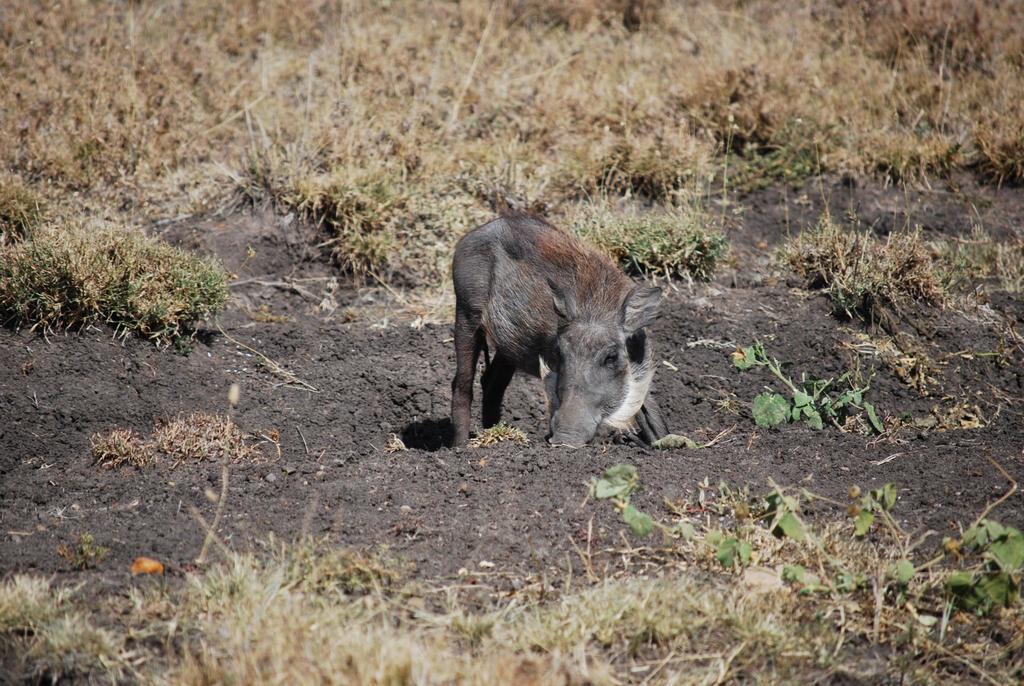Can you describe this image briefly? In this image I can see the ground which is black in color and an animal which is black and white in color on the ground. I can see some grass which is brown and cream in color on the ground. 